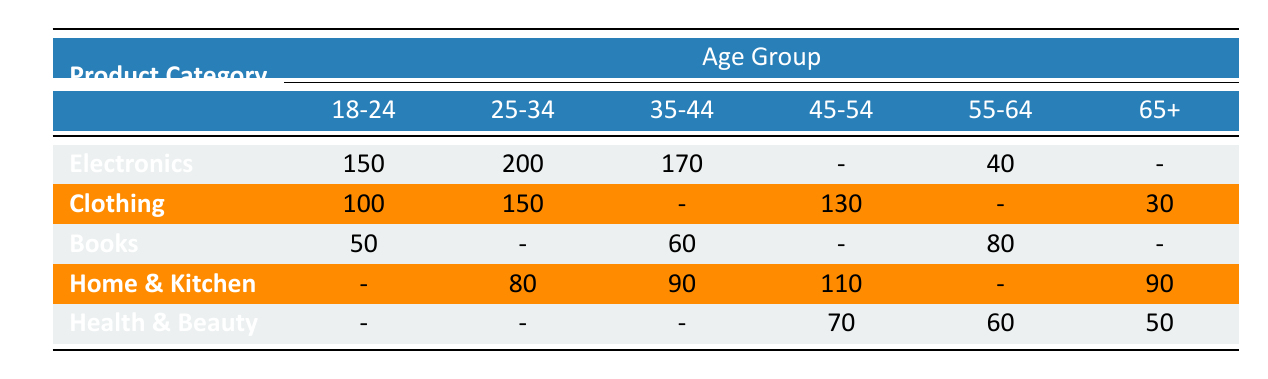What is the purchase count for Electronics in the age group 18-24? The purchase count for Electronics in the age group 18-24 is directly provided in the table. Looking at the "Electronics" row and the "18-24" column, the value is 150.
Answer: 150 Which product category has the highest total purchase count for the age group 25-34? For the age group 25-34, the purchase counts for each category are: Electronics (200), Clothing (150), Home & Kitchen (80). The highest is Electronics with 200.
Answer: Electronics Is the purchase count for Books in the age group 45-54 greater than in 35-44? The purchase count for Books in the age group 45-54 is 0 (not present), while in the age group 35-44 it is 60. Since 0 is less than 60, the statement is false.
Answer: No What is the total purchase count for Clothing across all age groups? To find the total for Clothing, we add the relevant counts: 100 (18-24) + 150 (25-34) + 0 (35-44) + 130 (45-54) + 0 (55-64) + 30 (65+) = 410.
Answer: 410 Are there any product categories with no purchases for the age group 55-64? Looking through the 55-64 row, there are no purchases recorded for Clothing and Home & Kitchen. Therefore, yes, there are categories with no purchases for this age group.
Answer: Yes What is the combined purchase count for Home & Kitchen in the age groups 25-34 and 35-44? The purchase count for Home & Kitchen in age group 25-34 is 80 and in 35-44 is 90. Adding these gives: 80 + 90 = 170.
Answer: 170 How does the purchase count of Health & Beauty in age group 65+ compare to that of Clothing in the same age group? The purchase count for Health & Beauty in age group 65+ is 50 and for Clothing is 30. Since 50 is greater than 30, Health & Beauty has a higher count in this age group.
Answer: Yes What is the average purchase count for Electronics across all age groups? To find the average, we first find the non-zero purchase counts for Electronics: 150 (18-24) + 200 (25-34) + 170 (35-44) + 40 (55-64) = 560. There are 4 age groups with counts, so the average is 560 / 4 = 140.
Answer: 140 